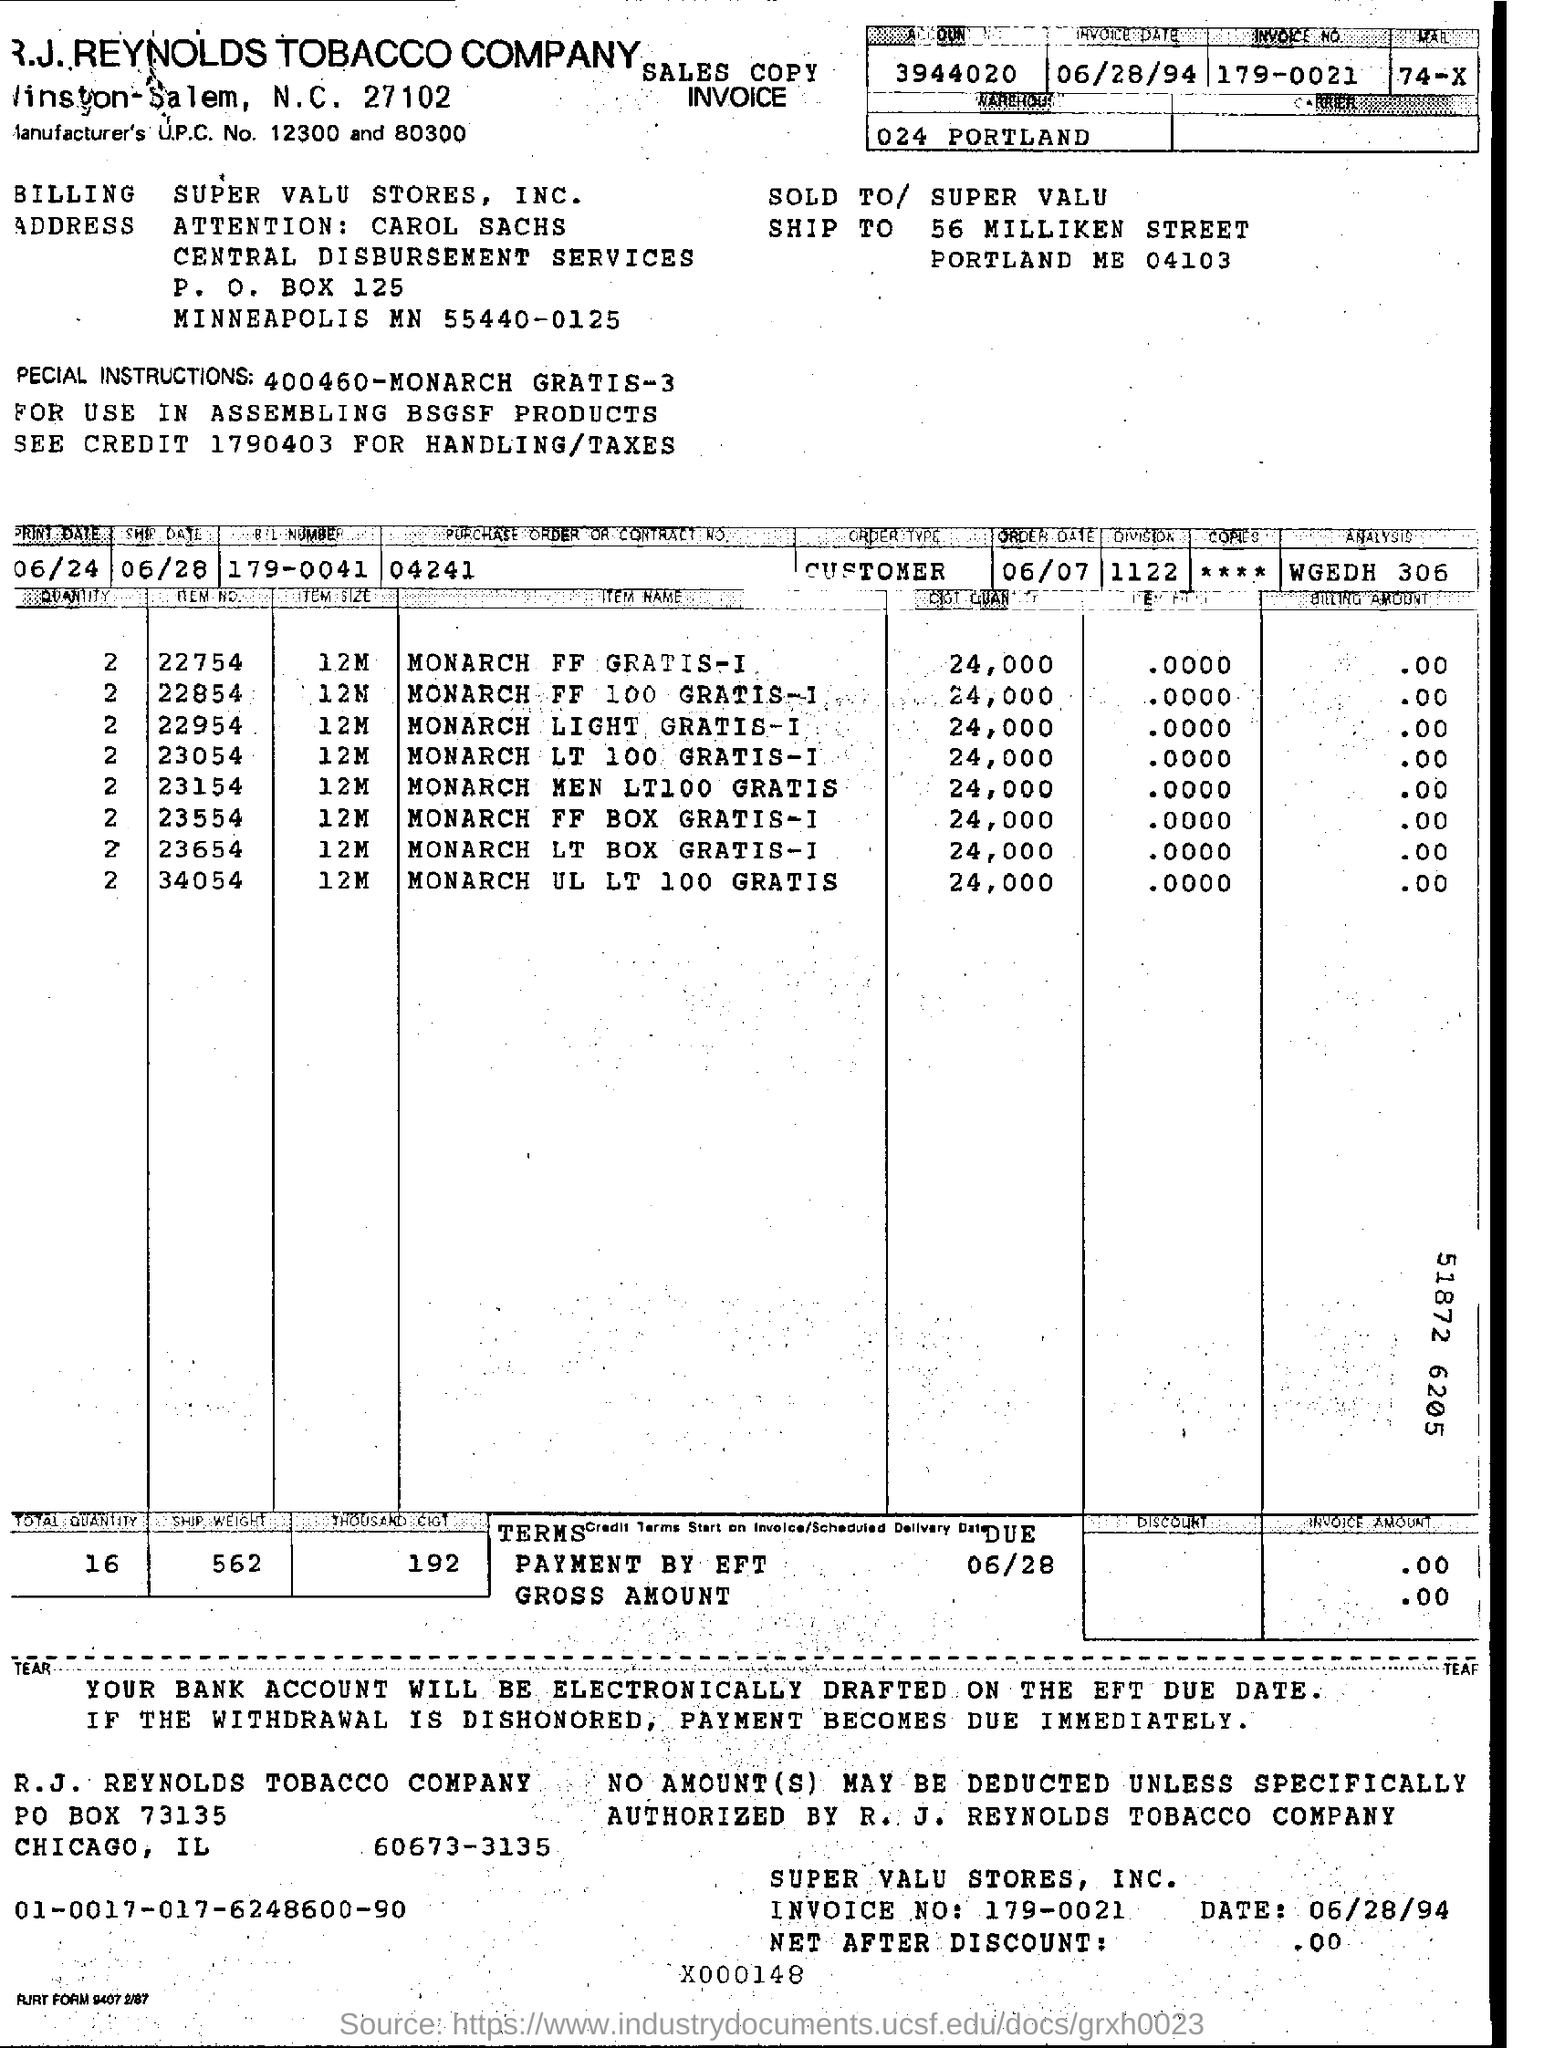What is invoice number ?
Keep it short and to the point. 179-0021. What is the purchase order or contract number ?
Provide a succinct answer. 04241. 